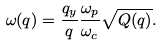<formula> <loc_0><loc_0><loc_500><loc_500>\omega ( { q } ) = \frac { q _ { y } } { q } \frac { \omega _ { p } } { \omega _ { c } } \sqrt { Q ( { q } ) } .</formula> 